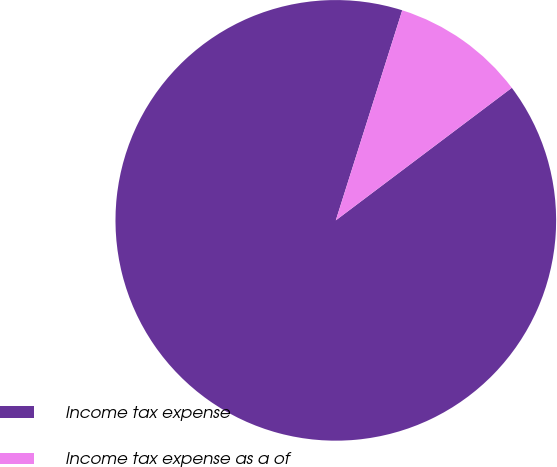Convert chart. <chart><loc_0><loc_0><loc_500><loc_500><pie_chart><fcel>Income tax expense<fcel>Income tax expense as a of<nl><fcel>90.15%<fcel>9.85%<nl></chart> 